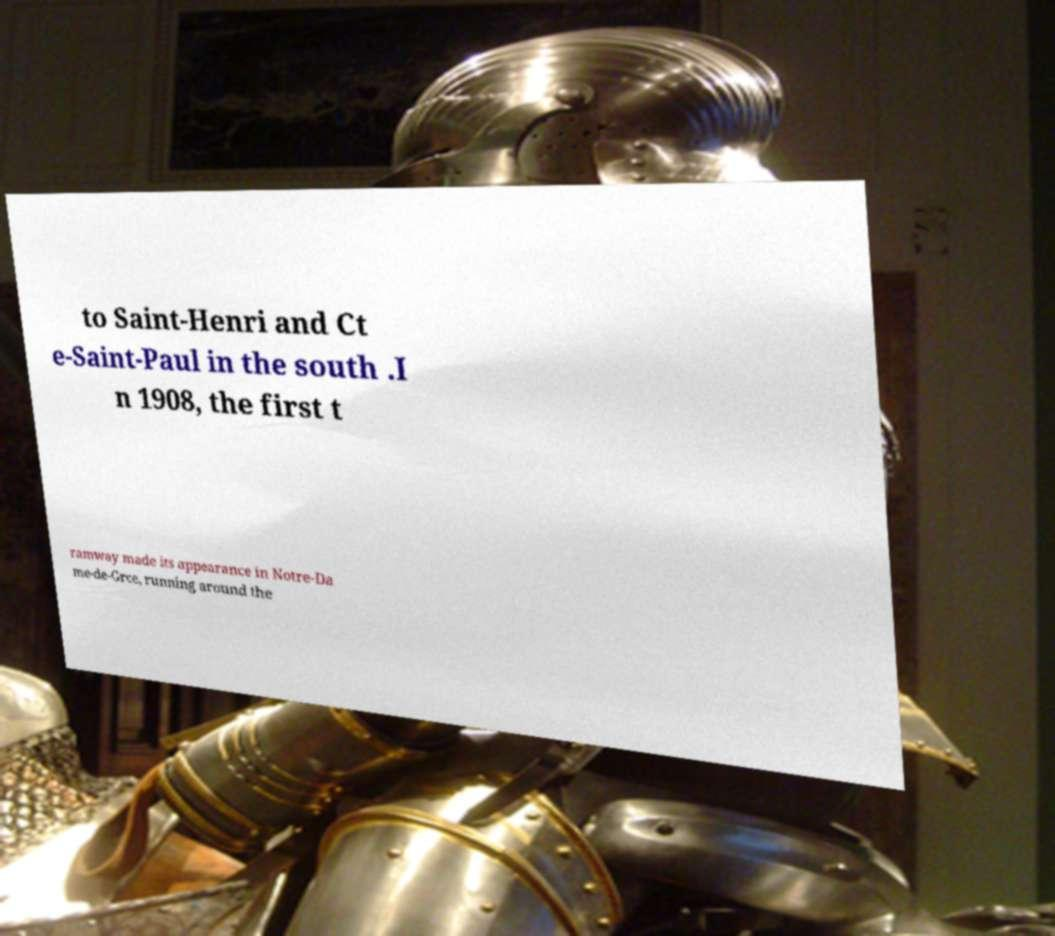What messages or text are displayed in this image? I need them in a readable, typed format. to Saint-Henri and Ct e-Saint-Paul in the south .I n 1908, the first t ramway made its appearance in Notre-Da me-de-Grce, running around the 